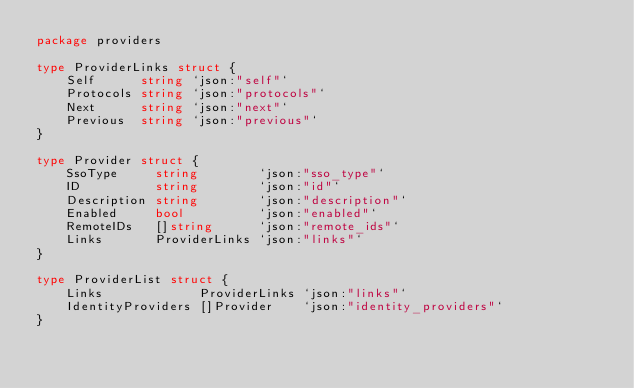Convert code to text. <code><loc_0><loc_0><loc_500><loc_500><_Go_>package providers

type ProviderLinks struct {
	Self      string `json:"self"`
	Protocols string `json:"protocols"`
	Next      string `json:"next"`
	Previous  string `json:"previous"`
}

type Provider struct {
	SsoType     string        `json:"sso_type"`
	ID          string        `json:"id"`
	Description string        `json:"description"`
	Enabled     bool          `json:"enabled"`
	RemoteIDs   []string      `json:"remote_ids"`
	Links       ProviderLinks `json:"links"`
}

type ProviderList struct {
	Links             ProviderLinks `json:"links"`
	IdentityProviders []Provider    `json:"identity_providers"`
}
</code> 